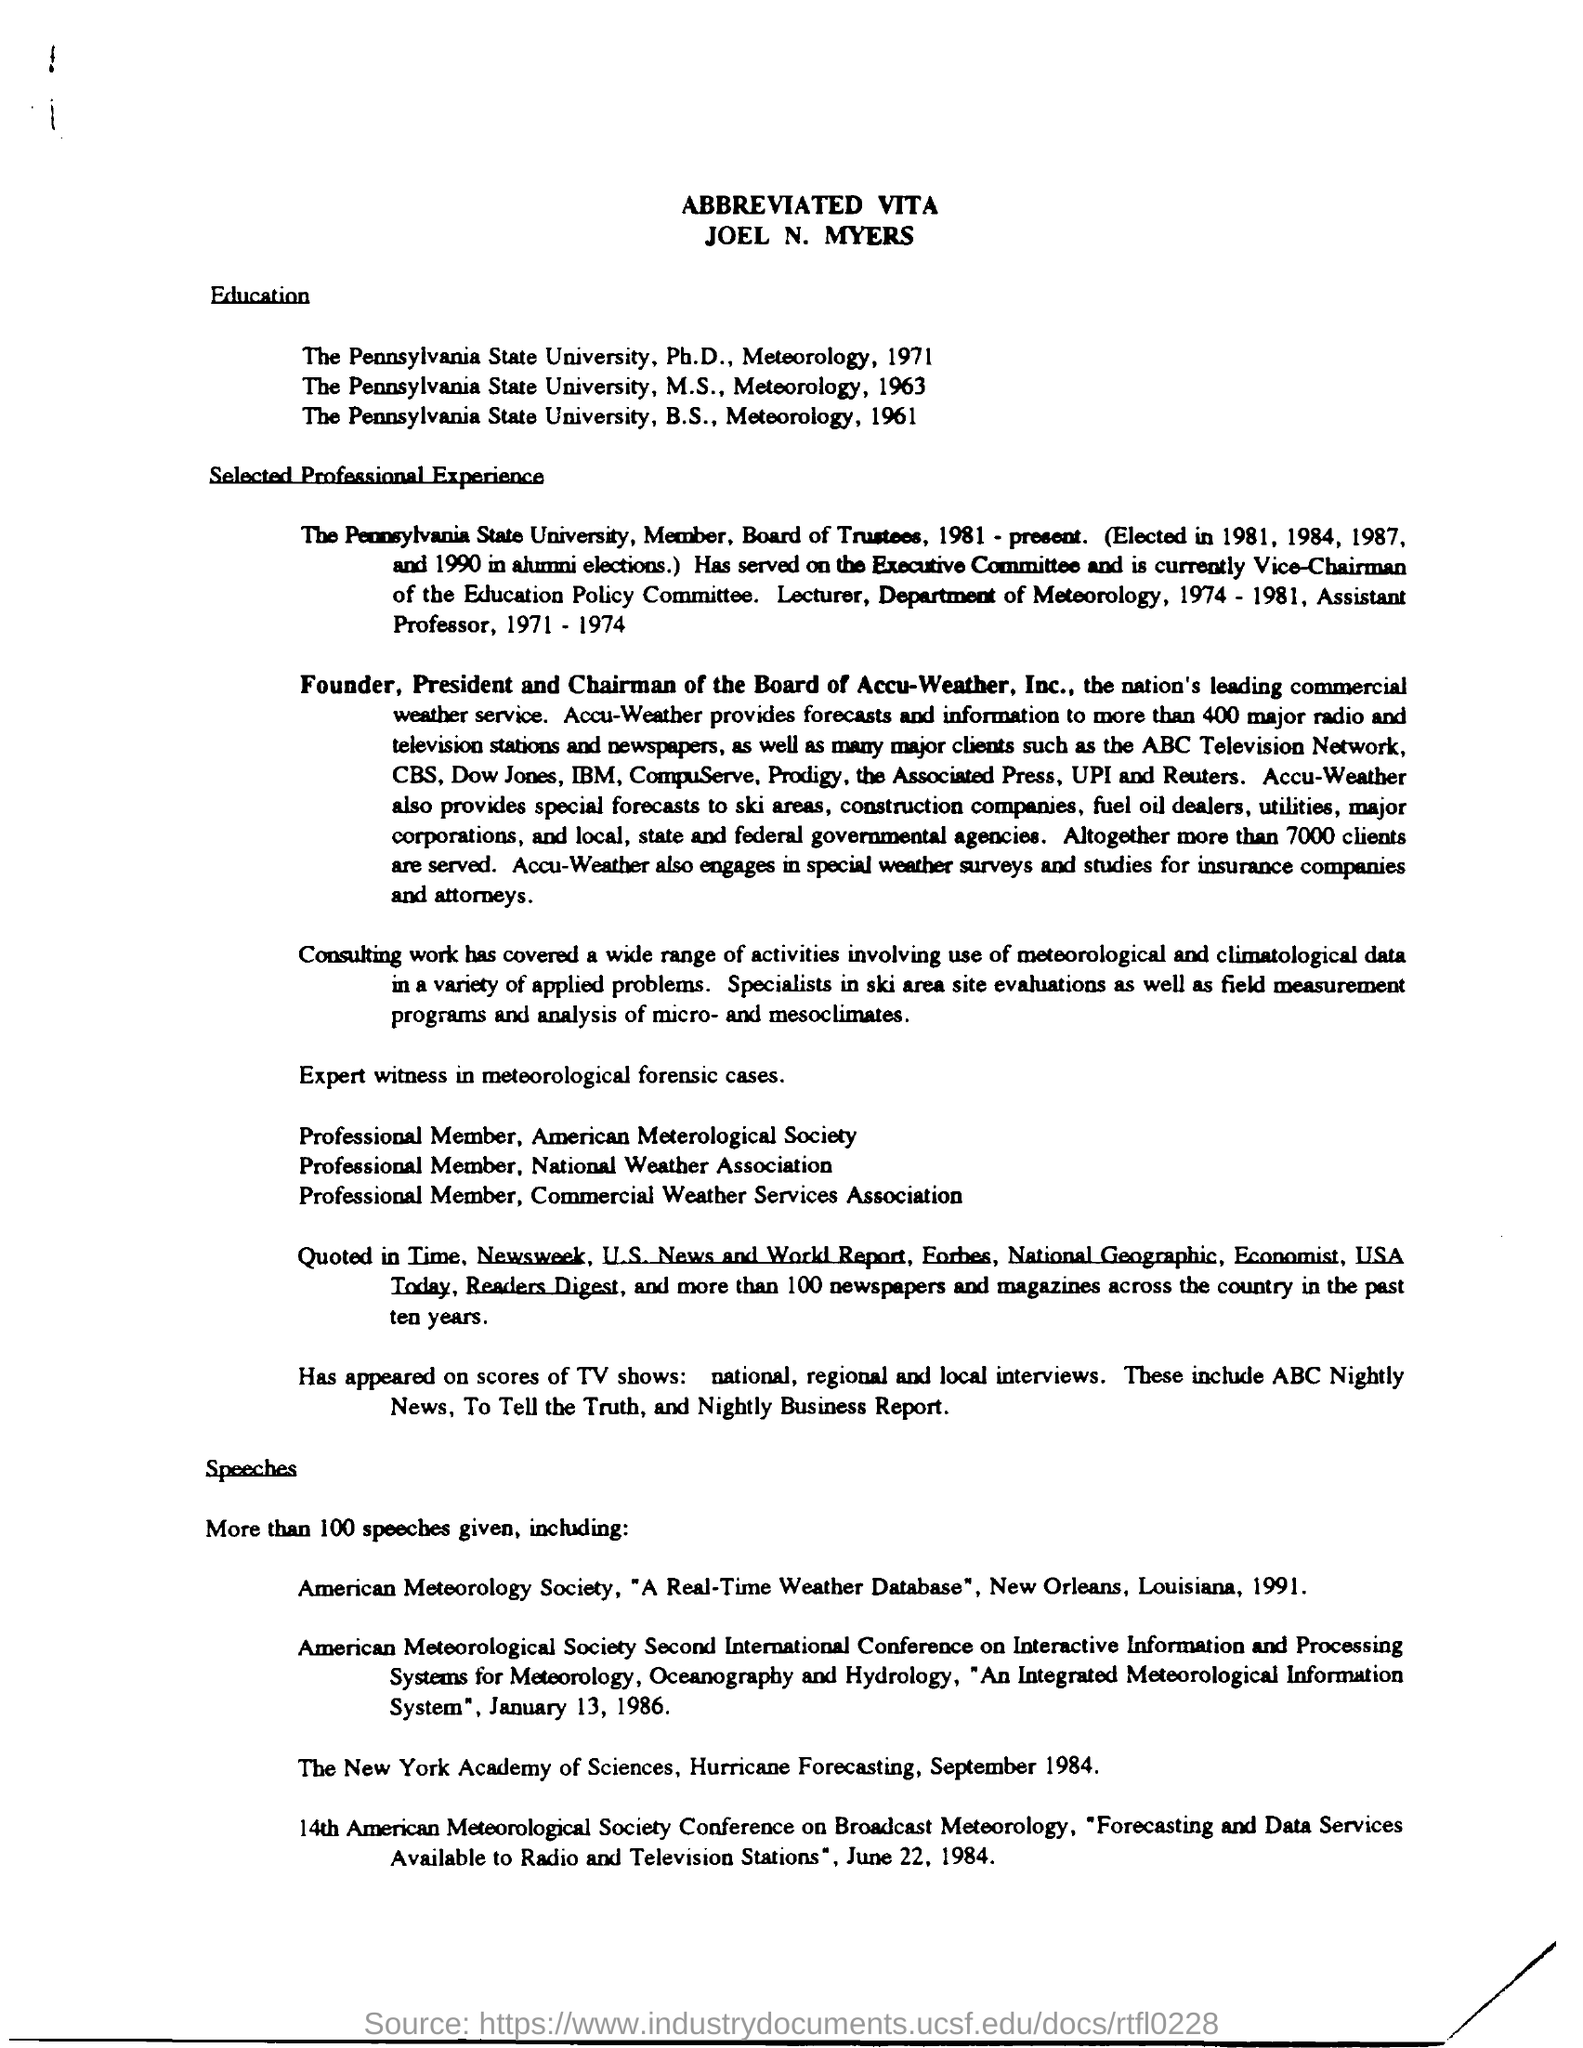Who is the founder,president and chairman of the Board of Accu-Weather,Inc.?
Give a very brief answer. Joel N. Myers. What is the title of the document?
Your answer should be very brief. ABBREVIATED VITA. 